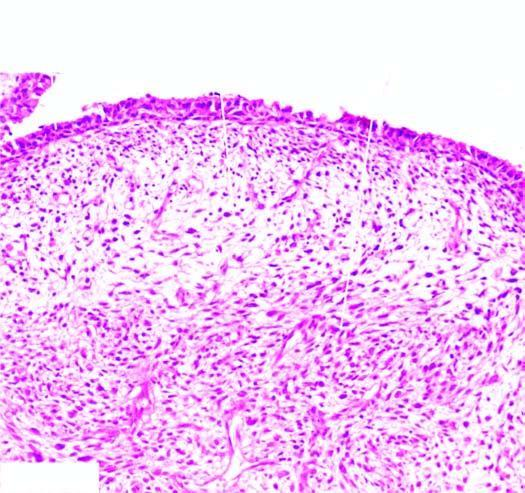does microscopy of the tumour show the characteristic submucosal cambium layer of tumour cells?
Answer the question using a single word or phrase. No 